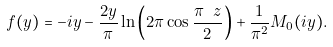Convert formula to latex. <formula><loc_0><loc_0><loc_500><loc_500>\ f ( y ) = - i y - \frac { 2 y } { \pi } \ln \left ( 2 \pi \cos \frac { \pi \ z } { 2 } \right ) + \frac { 1 } { \pi ^ { 2 } } M _ { 0 } ( i y ) .</formula> 